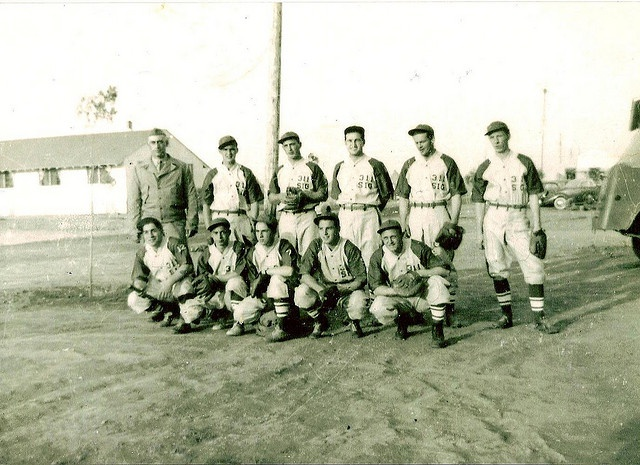Describe the objects in this image and their specific colors. I can see people in white, beige, black, and darkgray tones, people in white, black, darkgreen, darkgray, and beige tones, people in white, beige, black, and darkgreen tones, people in white, black, darkgreen, beige, and darkgray tones, and people in white, darkgray, beige, black, and olive tones in this image. 